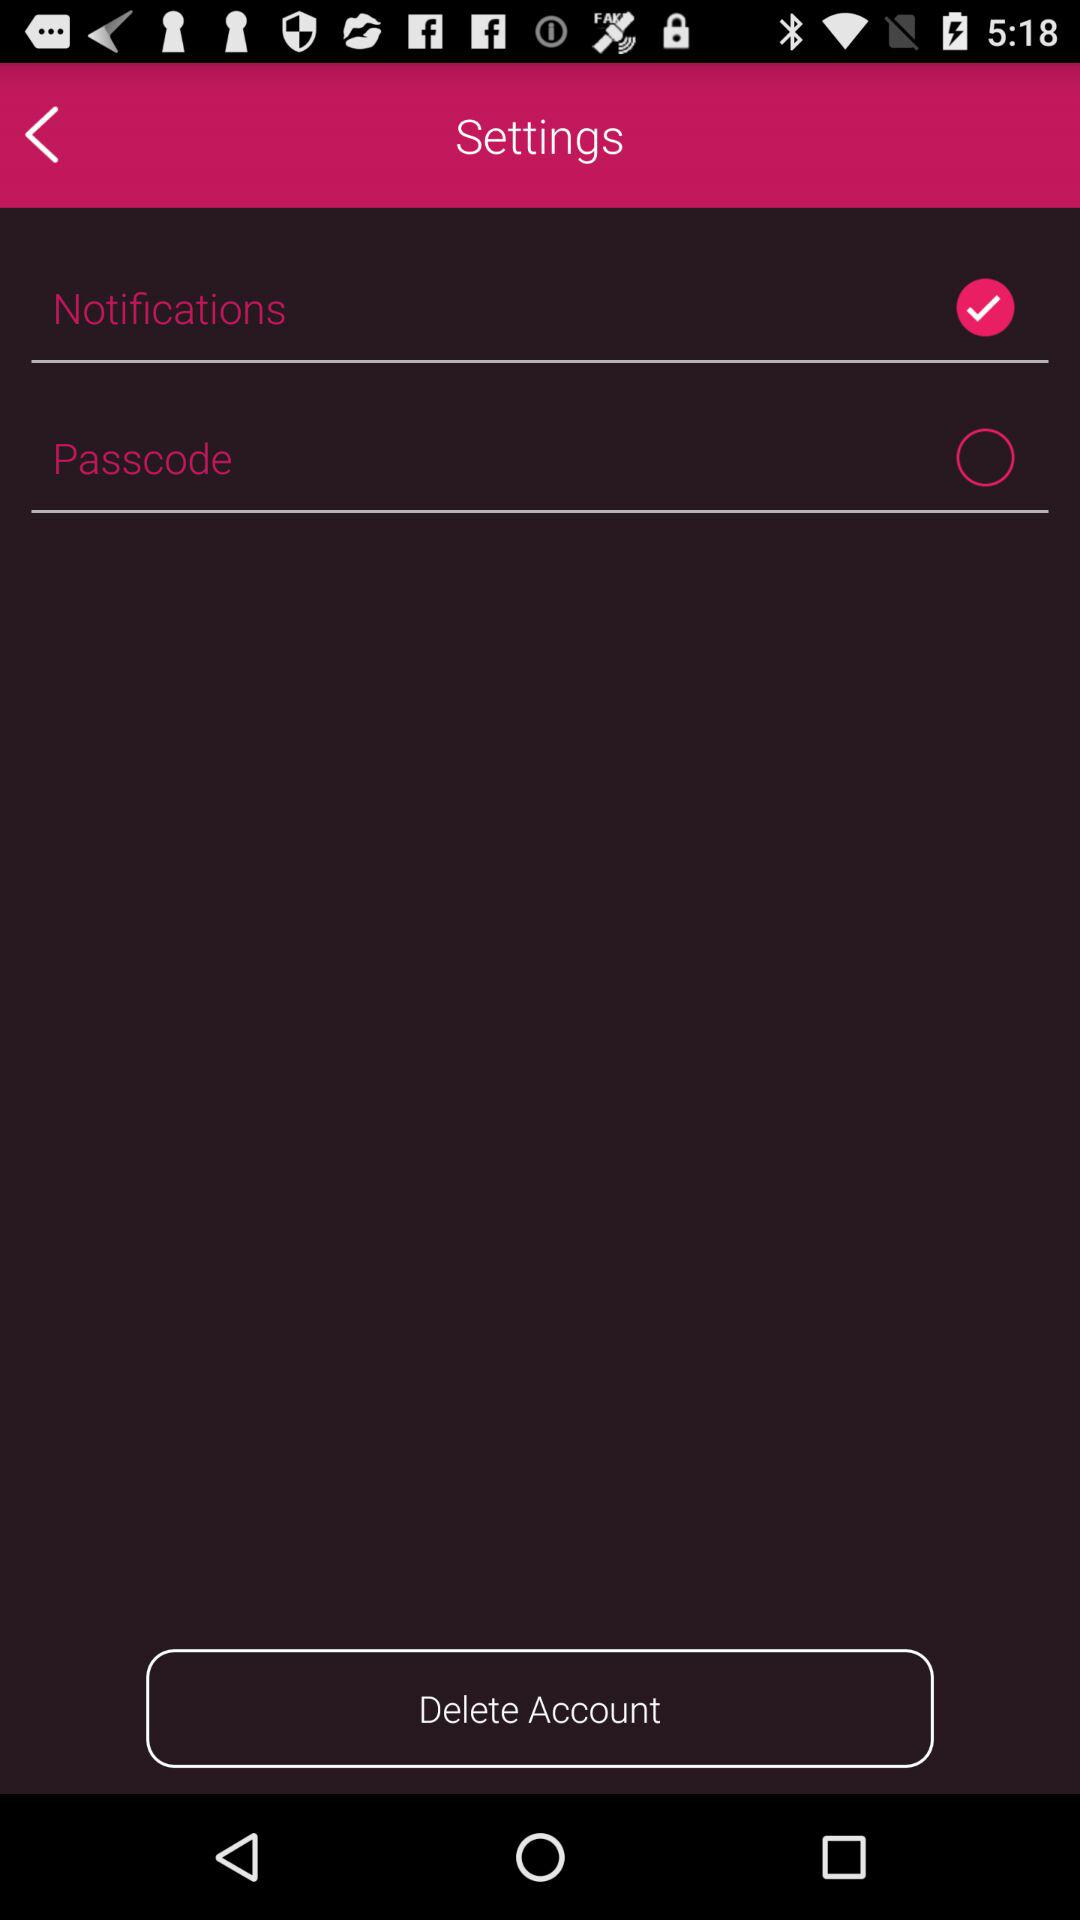What is the status of "Notifications"? The status is "on". 